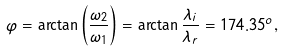<formula> <loc_0><loc_0><loc_500><loc_500>\varphi = \arctan \left ( \frac { \omega _ { 2 } } { \omega _ { 1 } } \right ) = \arctan \frac { \lambda _ { i } } { \lambda _ { r } } = 1 7 4 . 3 5 ^ { o } ,</formula> 